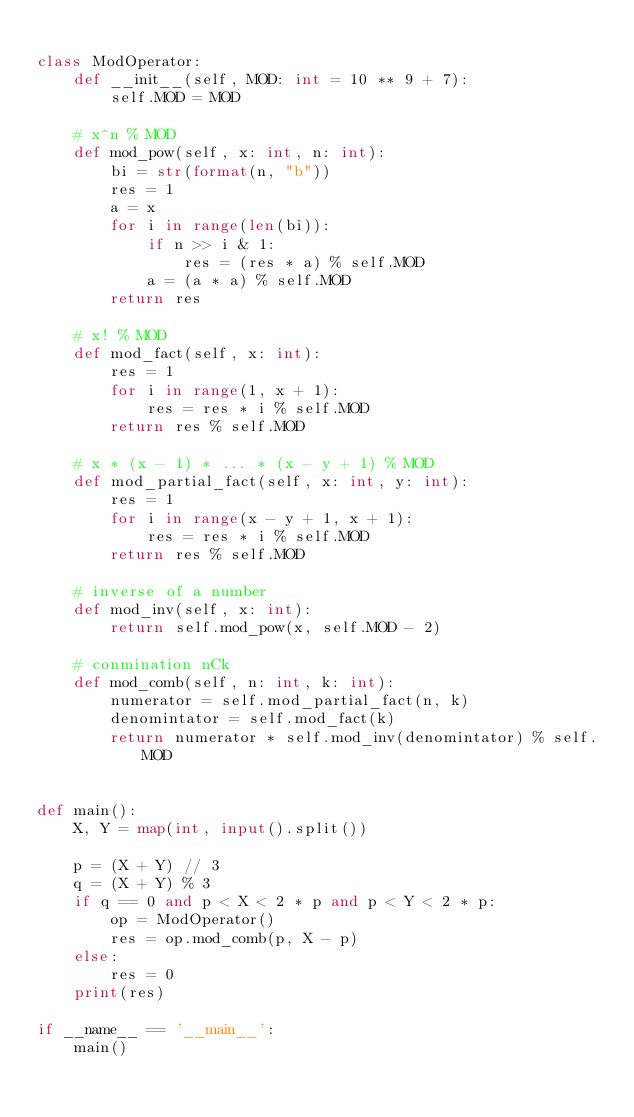Convert code to text. <code><loc_0><loc_0><loc_500><loc_500><_Python_>
class ModOperator:
    def __init__(self, MOD: int = 10 ** 9 + 7):
        self.MOD = MOD

    # x^n % MOD
    def mod_pow(self, x: int, n: int):
        bi = str(format(n, "b"))
        res = 1
        a = x
        for i in range(len(bi)):
            if n >> i & 1:
                res = (res * a) % self.MOD
            a = (a * a) % self.MOD
        return res
    
    # x! % MOD
    def mod_fact(self, x: int):
        res = 1
        for i in range(1, x + 1):
            res = res * i % self.MOD
        return res % self.MOD

    # x * (x - 1) * ... * (x - y + 1) % MOD
    def mod_partial_fact(self, x: int, y: int):
        res = 1
        for i in range(x - y + 1, x + 1):
            res = res * i % self.MOD
        return res % self.MOD

    # inverse of a number
    def mod_inv(self, x: int):
        return self.mod_pow(x, self.MOD - 2)
    
    # conmination nCk
    def mod_comb(self, n: int, k: int):
        numerator = self.mod_partial_fact(n, k)
        denomintator = self.mod_fact(k)
        return numerator * self.mod_inv(denomintator) % self.MOD


def main():
    X, Y = map(int, input().split())

    p = (X + Y) // 3
    q = (X + Y) % 3
    if q == 0 and p < X < 2 * p and p < Y < 2 * p:
        op = ModOperator()
        res = op.mod_comb(p, X - p)
    else:
        res = 0
    print(res)

if __name__ == '__main__':
    main()</code> 